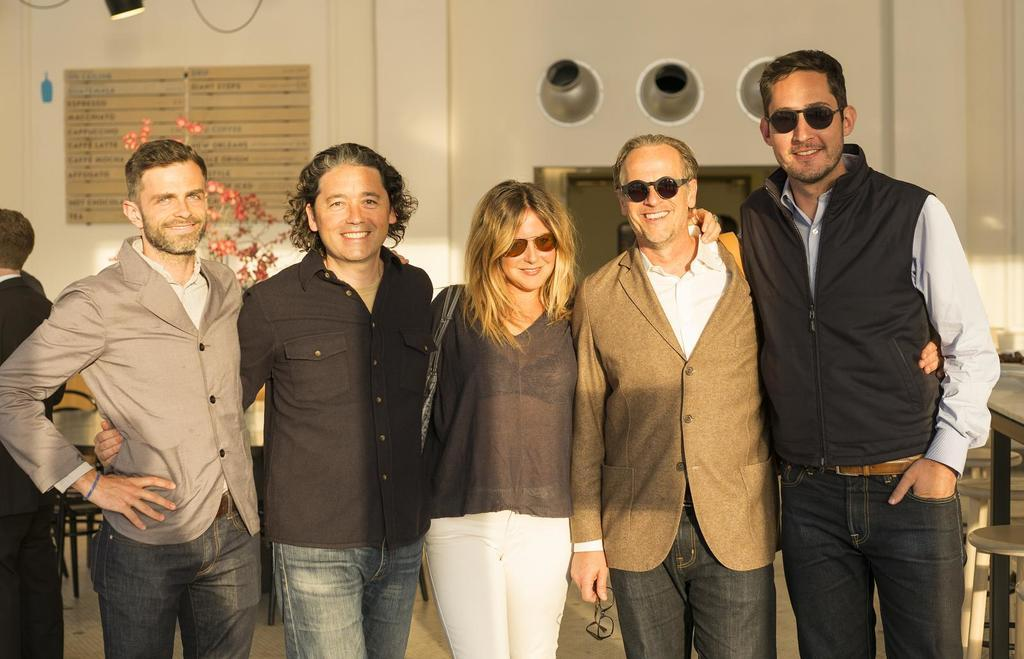Who is present in the image? There are people in the image. What are the people doing in the image? The people are smiling and posing for the camera. What can be seen in the background of the image? There are tables and chairs in the background. What is on the wall in the image? There is a name board on the wall. What type of leather is covering the root in the image? There is no leather or root present in the image. 